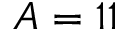<formula> <loc_0><loc_0><loc_500><loc_500>A = 1 1</formula> 